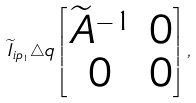<formula> <loc_0><loc_0><loc_500><loc_500>{ { \widetilde { I } } _ { i { p _ { 1 } } } } \triangle q \left [ \begin{matrix} { { \widetilde { A } } ^ { - 1 } } & { 0 } \\ { 0 } & { 0 } \end{matrix} \right ] ,</formula> 